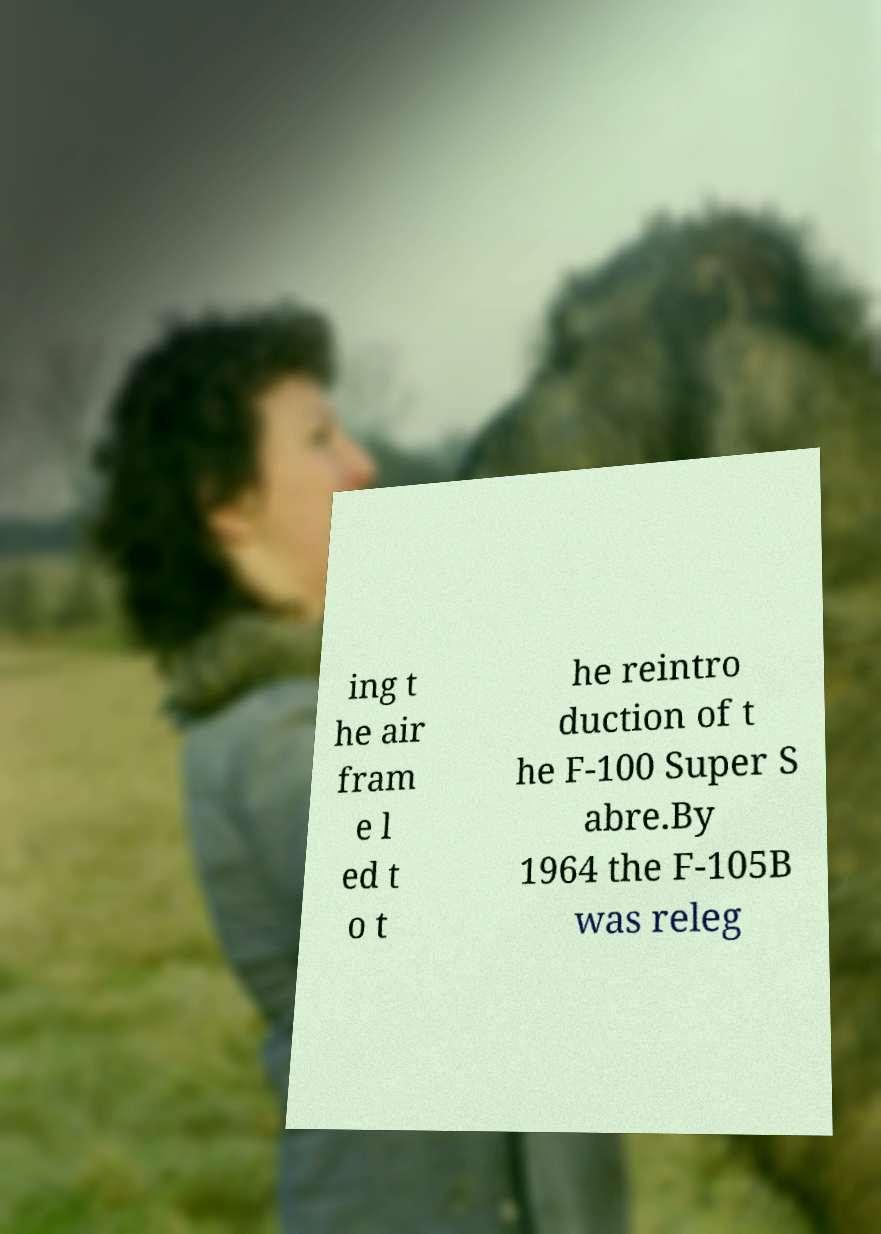Can you accurately transcribe the text from the provided image for me? ing t he air fram e l ed t o t he reintro duction of t he F-100 Super S abre.By 1964 the F-105B was releg 